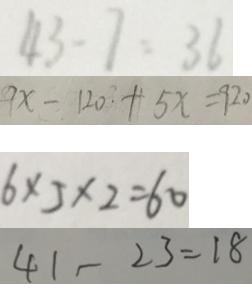<formula> <loc_0><loc_0><loc_500><loc_500>4 3 - 7 = 3 6 
 9 x - 1 2 0 + 5 x = 9 2 0 
 6 \times 5 \times 2 = 6 0 
 4 1 - 2 3 = 1 8</formula> 